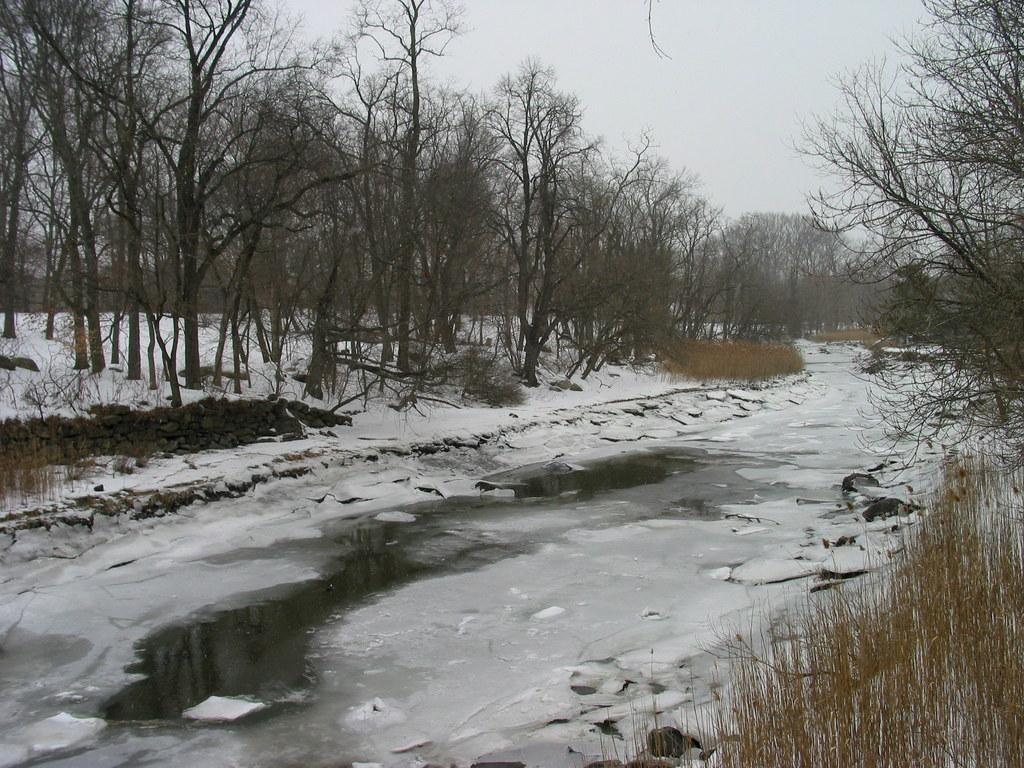What is located in the middle of the picture? There is water in the middle of the picture. What type of vegetation can be seen in the picture? There is grass and trees in the picture. What is visible in the background of the picture? The sky is visible in the background of the picture. What type of letter can be seen floating on the water in the image? There is no letter present in the image; it only features water, grass, trees, and the sky. 